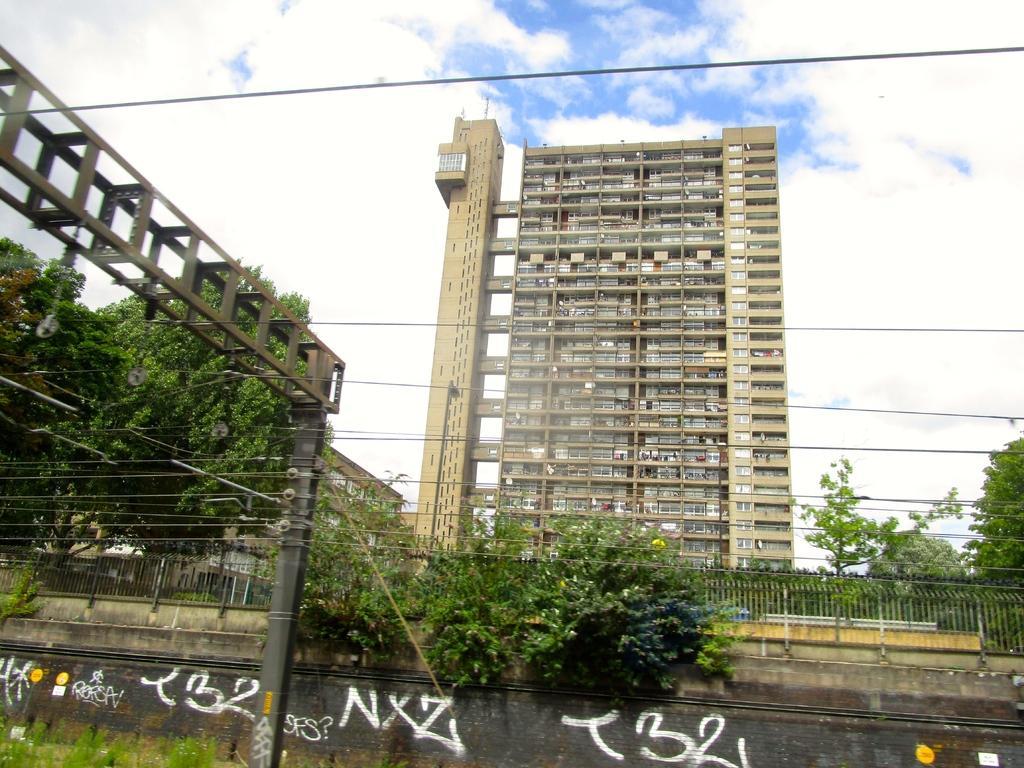How would you summarize this image in a sentence or two? In this image I can see a fence, poles, wires, trees, metal rods, buildings and the sky. This image is taken may be during a day. 